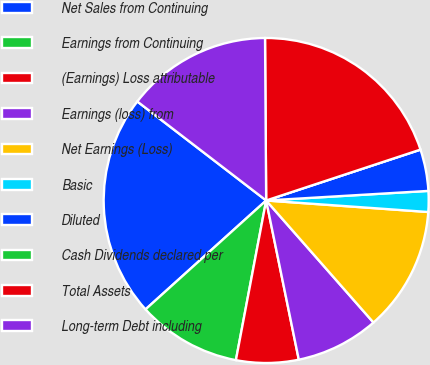Convert chart. <chart><loc_0><loc_0><loc_500><loc_500><pie_chart><fcel>Net Sales from Continuing<fcel>Earnings from Continuing<fcel>(Earnings) Loss attributable<fcel>Earnings (loss) from<fcel>Net Earnings (Loss)<fcel>Basic<fcel>Diluted<fcel>Cash Dividends declared per<fcel>Total Assets<fcel>Long-term Debt including<nl><fcel>22.11%<fcel>10.33%<fcel>6.2%<fcel>8.26%<fcel>12.39%<fcel>2.07%<fcel>4.13%<fcel>0.0%<fcel>20.04%<fcel>14.46%<nl></chart> 